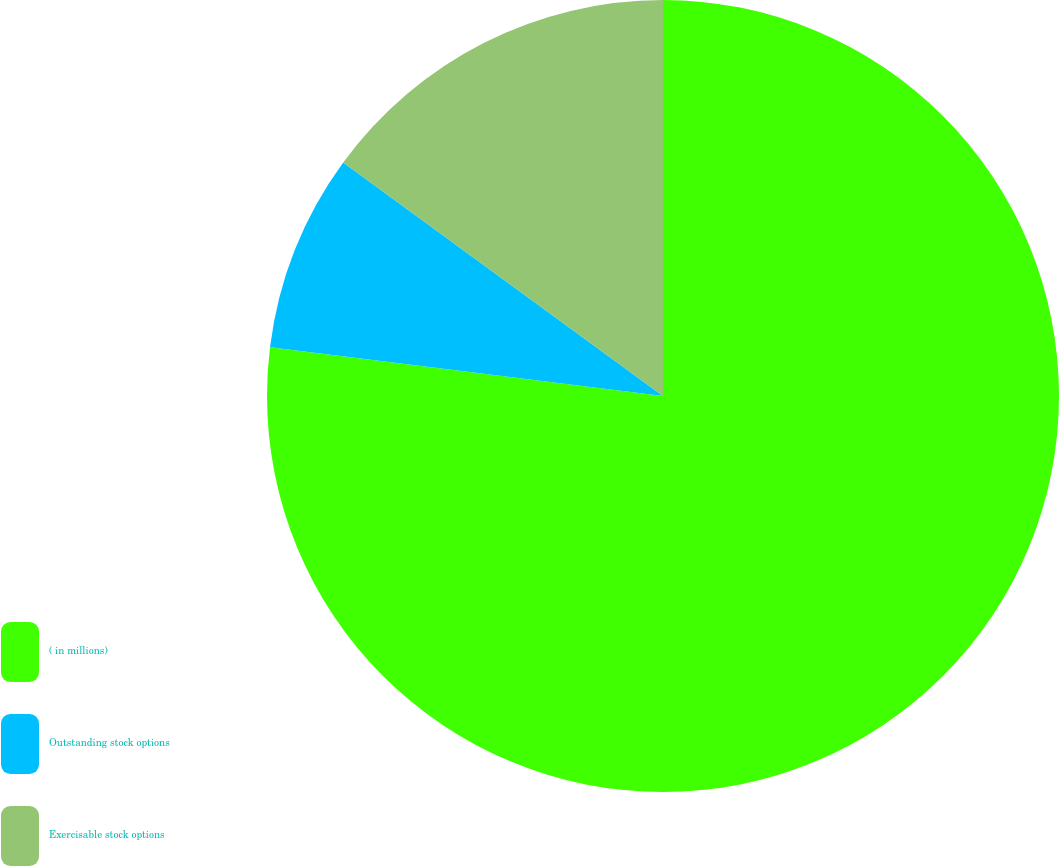<chart> <loc_0><loc_0><loc_500><loc_500><pie_chart><fcel>( in millions)<fcel>Outstanding stock options<fcel>Exercisable stock options<nl><fcel>76.96%<fcel>8.08%<fcel>14.96%<nl></chart> 